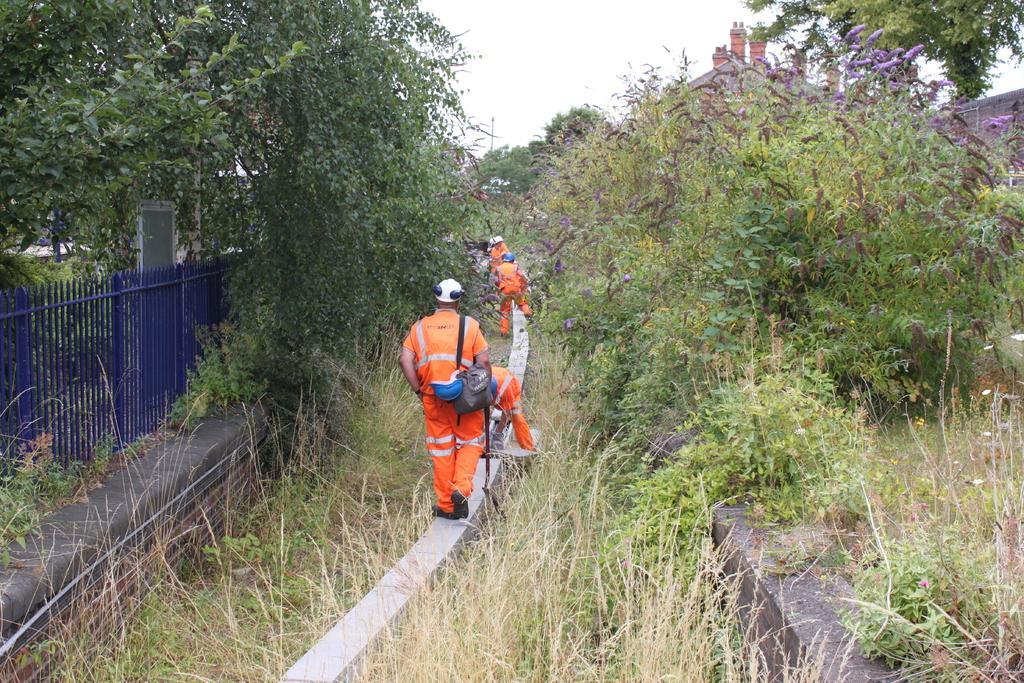How would you summarize this image in a sentence or two? In this image we can see some persons wearing similar color dress which is of orange walking on the white color cement pole there are some trees on left and right side of the image and in the background of the image there are some houses and clear sky. 